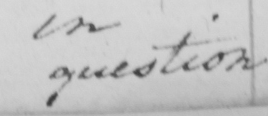What text is written in this handwritten line? question . 